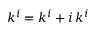Convert formula to latex. <formula><loc_0><loc_0><loc_500><loc_500>k ^ { i } = k ^ { i } + i \, k ^ { i }</formula> 